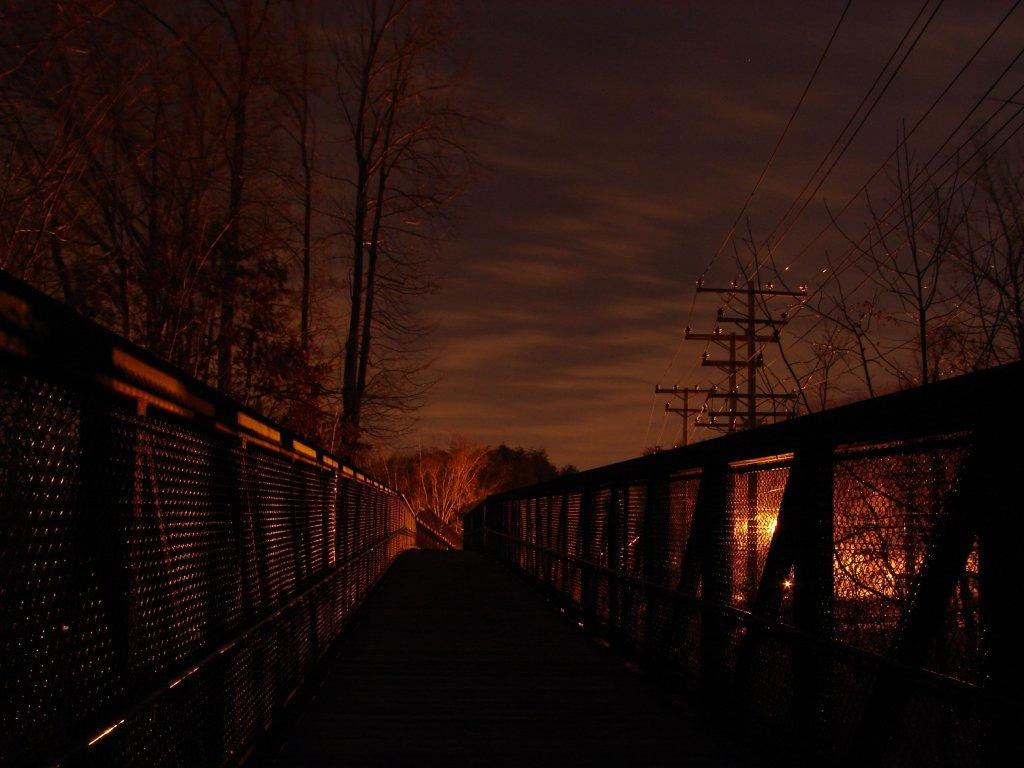What structure is the main subject of the image? There is a bridge in the image. What can be seen on the sides of the bridge? There are railings on both the right and left sides of the bridge. What is visible in the background of the image? There are trees, utility poles, and the sky visible in the background of the image. Can you see a zebra crossing the bridge in the image? There is no zebra present in the image, and therefore no such activity can be observed. 